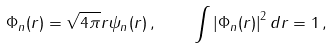<formula> <loc_0><loc_0><loc_500><loc_500>\Phi _ { n } ( r ) = \sqrt { 4 \pi } r \psi _ { n } ( r ) \, , \quad \int \left | \Phi _ { n } ( r ) \right | ^ { 2 } d r = 1 \, ,</formula> 